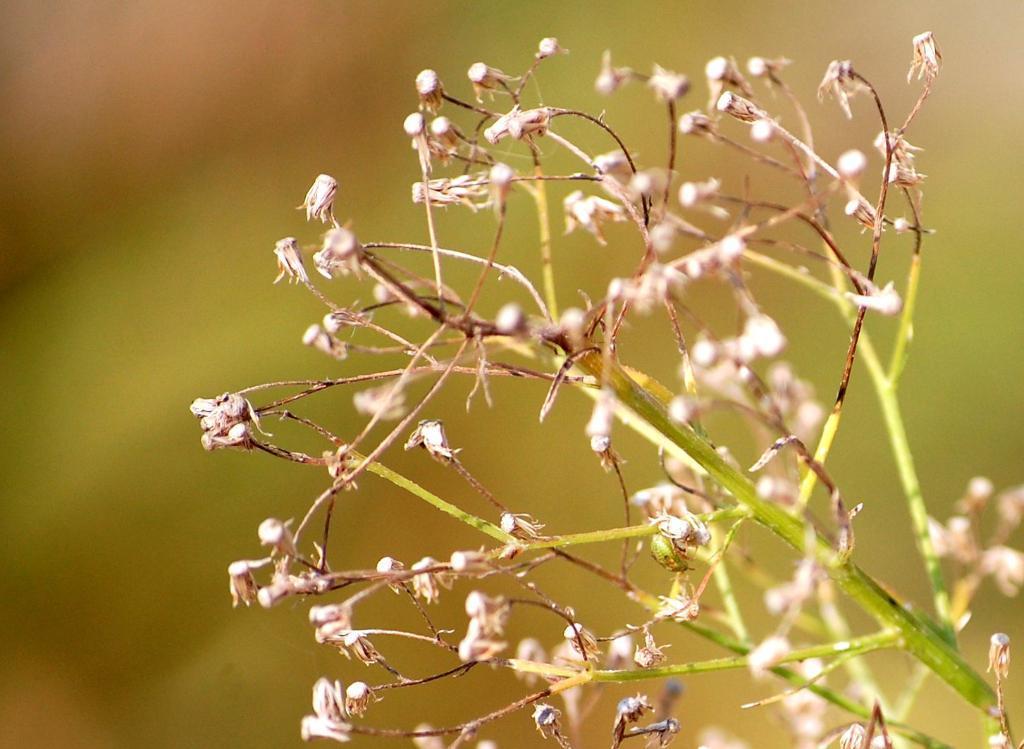How would you summarize this image in a sentence or two? This image is taken outdoors. In this image the background is a little blurred. On the right side of the image there is a plant with stems and seeds. 